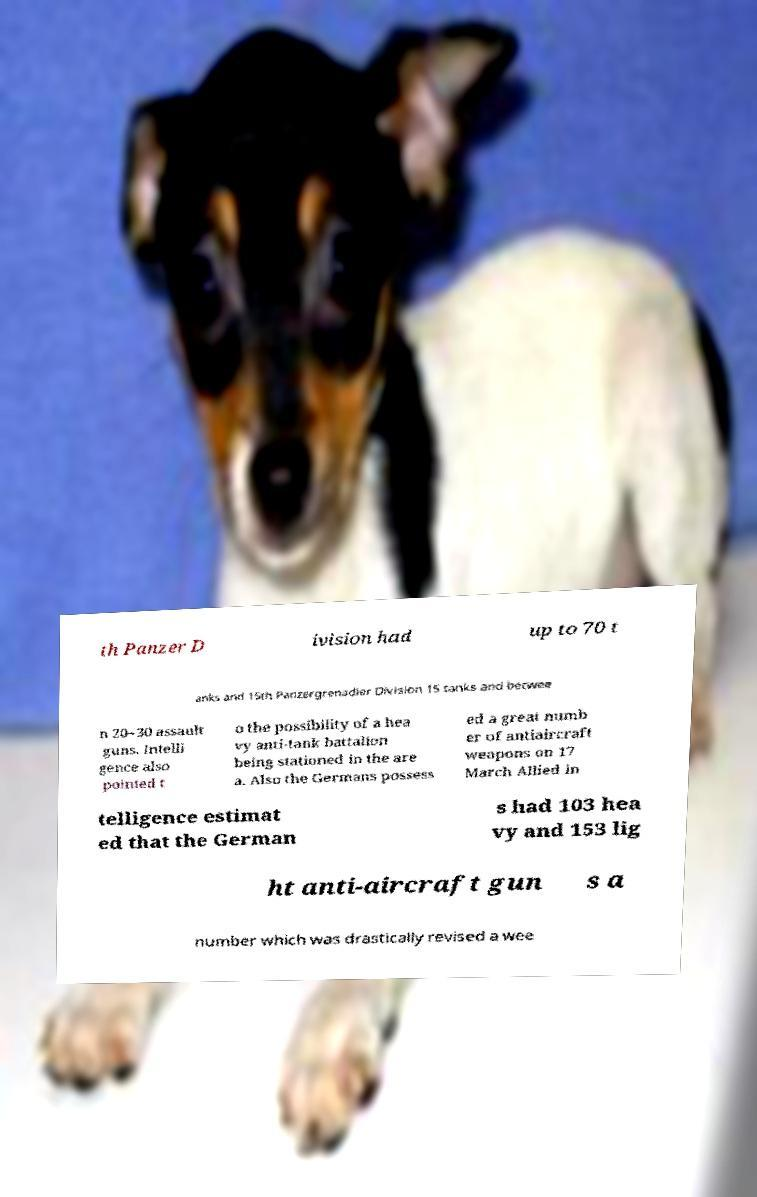There's text embedded in this image that I need extracted. Can you transcribe it verbatim? th Panzer D ivision had up to 70 t anks and 15th Panzergrenadier Division 15 tanks and betwee n 20–30 assault guns. Intelli gence also pointed t o the possibility of a hea vy anti-tank battalion being stationed in the are a. Also the Germans possess ed a great numb er of antiaircraft weapons on 17 March Allied in telligence estimat ed that the German s had 103 hea vy and 153 lig ht anti-aircraft gun s a number which was drastically revised a wee 